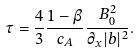<formula> <loc_0><loc_0><loc_500><loc_500>\tau = \frac { 4 } { 3 } \frac { 1 - \beta } { c _ { A } } \frac { B _ { 0 } ^ { 2 } } { \partial _ { x } | b | ^ { 2 } } .</formula> 